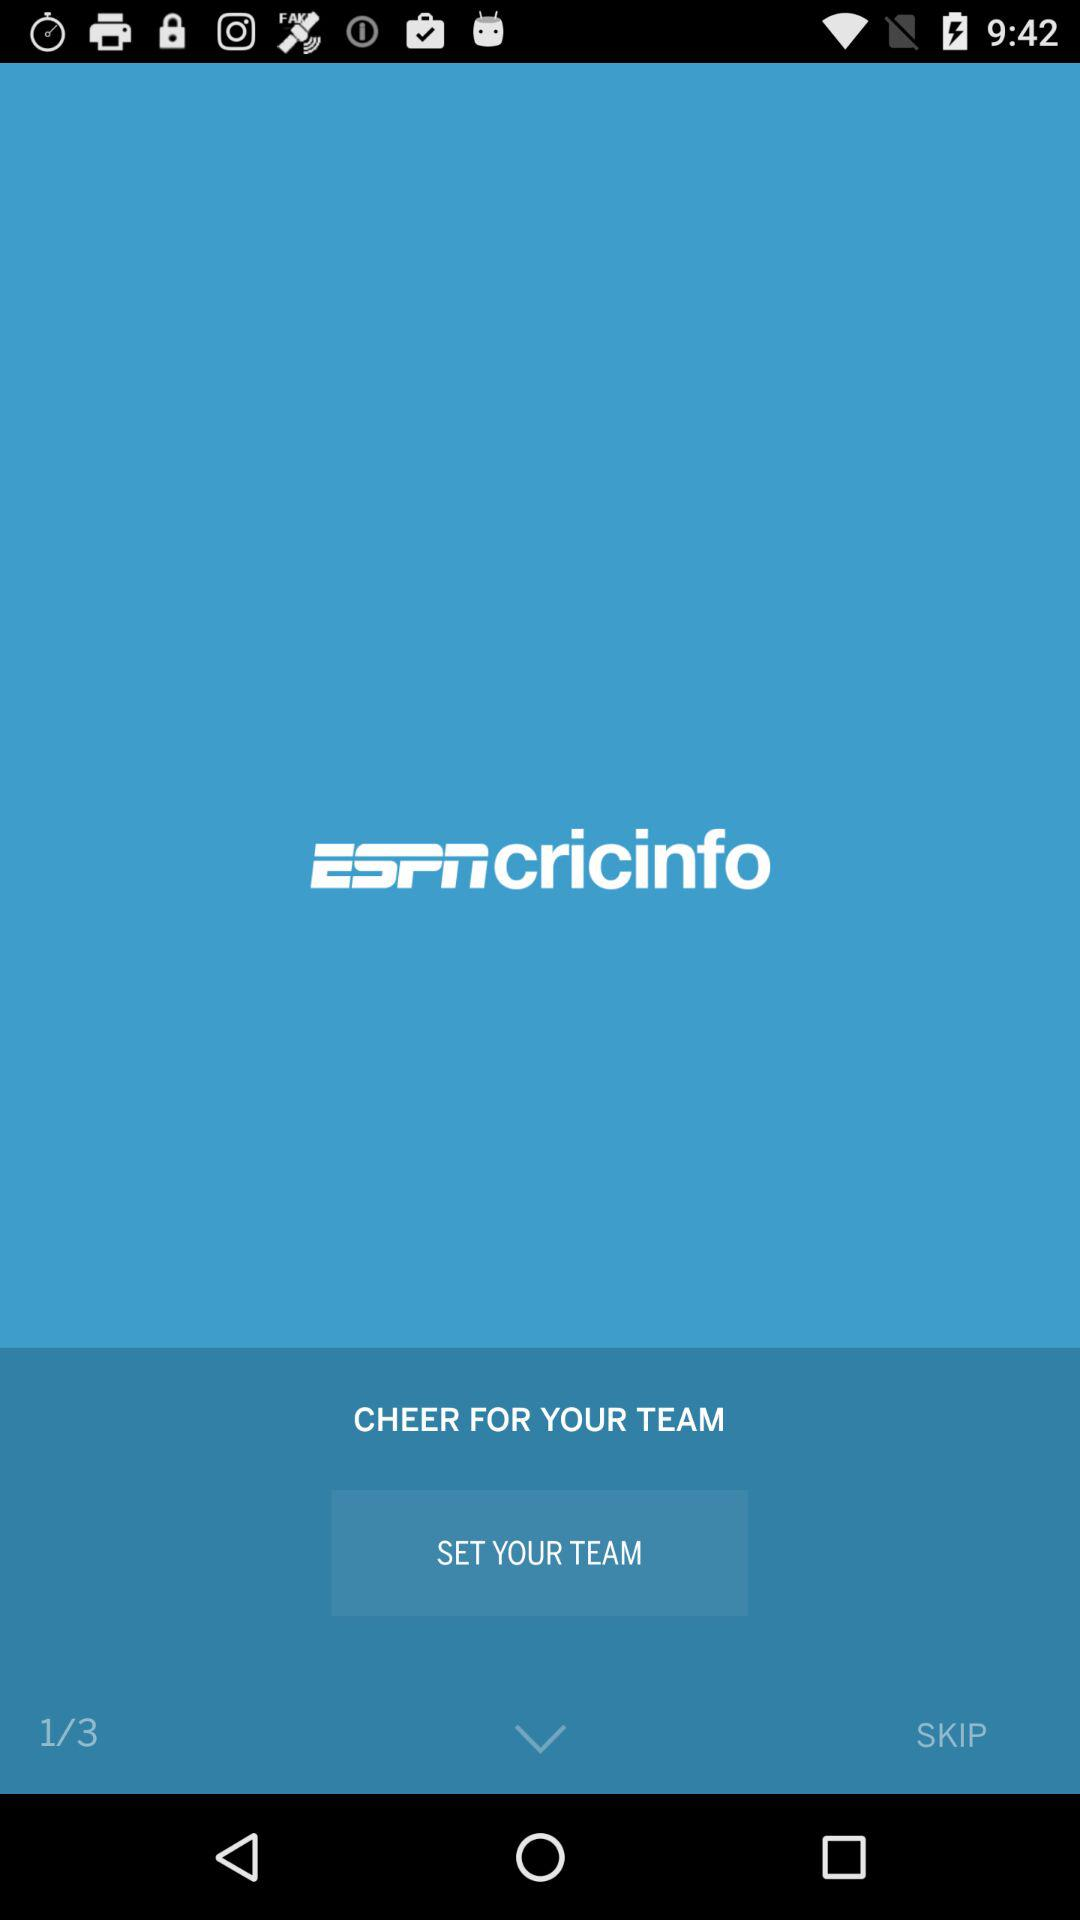Which step is currently shown?
Answer the question using a single word or phrase. Step 1 is currently shown 